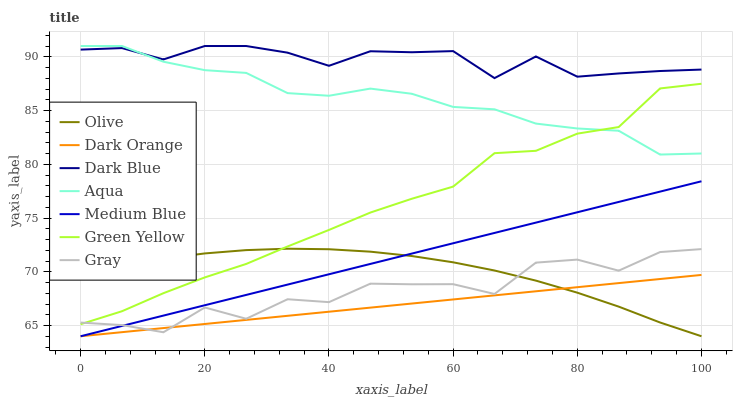Does Dark Orange have the minimum area under the curve?
Answer yes or no. Yes. Does Dark Blue have the maximum area under the curve?
Answer yes or no. Yes. Does Gray have the minimum area under the curve?
Answer yes or no. No. Does Gray have the maximum area under the curve?
Answer yes or no. No. Is Dark Orange the smoothest?
Answer yes or no. Yes. Is Gray the roughest?
Answer yes or no. Yes. Is Medium Blue the smoothest?
Answer yes or no. No. Is Medium Blue the roughest?
Answer yes or no. No. Does Dark Orange have the lowest value?
Answer yes or no. Yes. Does Gray have the lowest value?
Answer yes or no. No. Does Dark Blue have the highest value?
Answer yes or no. Yes. Does Gray have the highest value?
Answer yes or no. No. Is Dark Orange less than Green Yellow?
Answer yes or no. Yes. Is Green Yellow greater than Medium Blue?
Answer yes or no. Yes. Does Olive intersect Medium Blue?
Answer yes or no. Yes. Is Olive less than Medium Blue?
Answer yes or no. No. Is Olive greater than Medium Blue?
Answer yes or no. No. Does Dark Orange intersect Green Yellow?
Answer yes or no. No. 